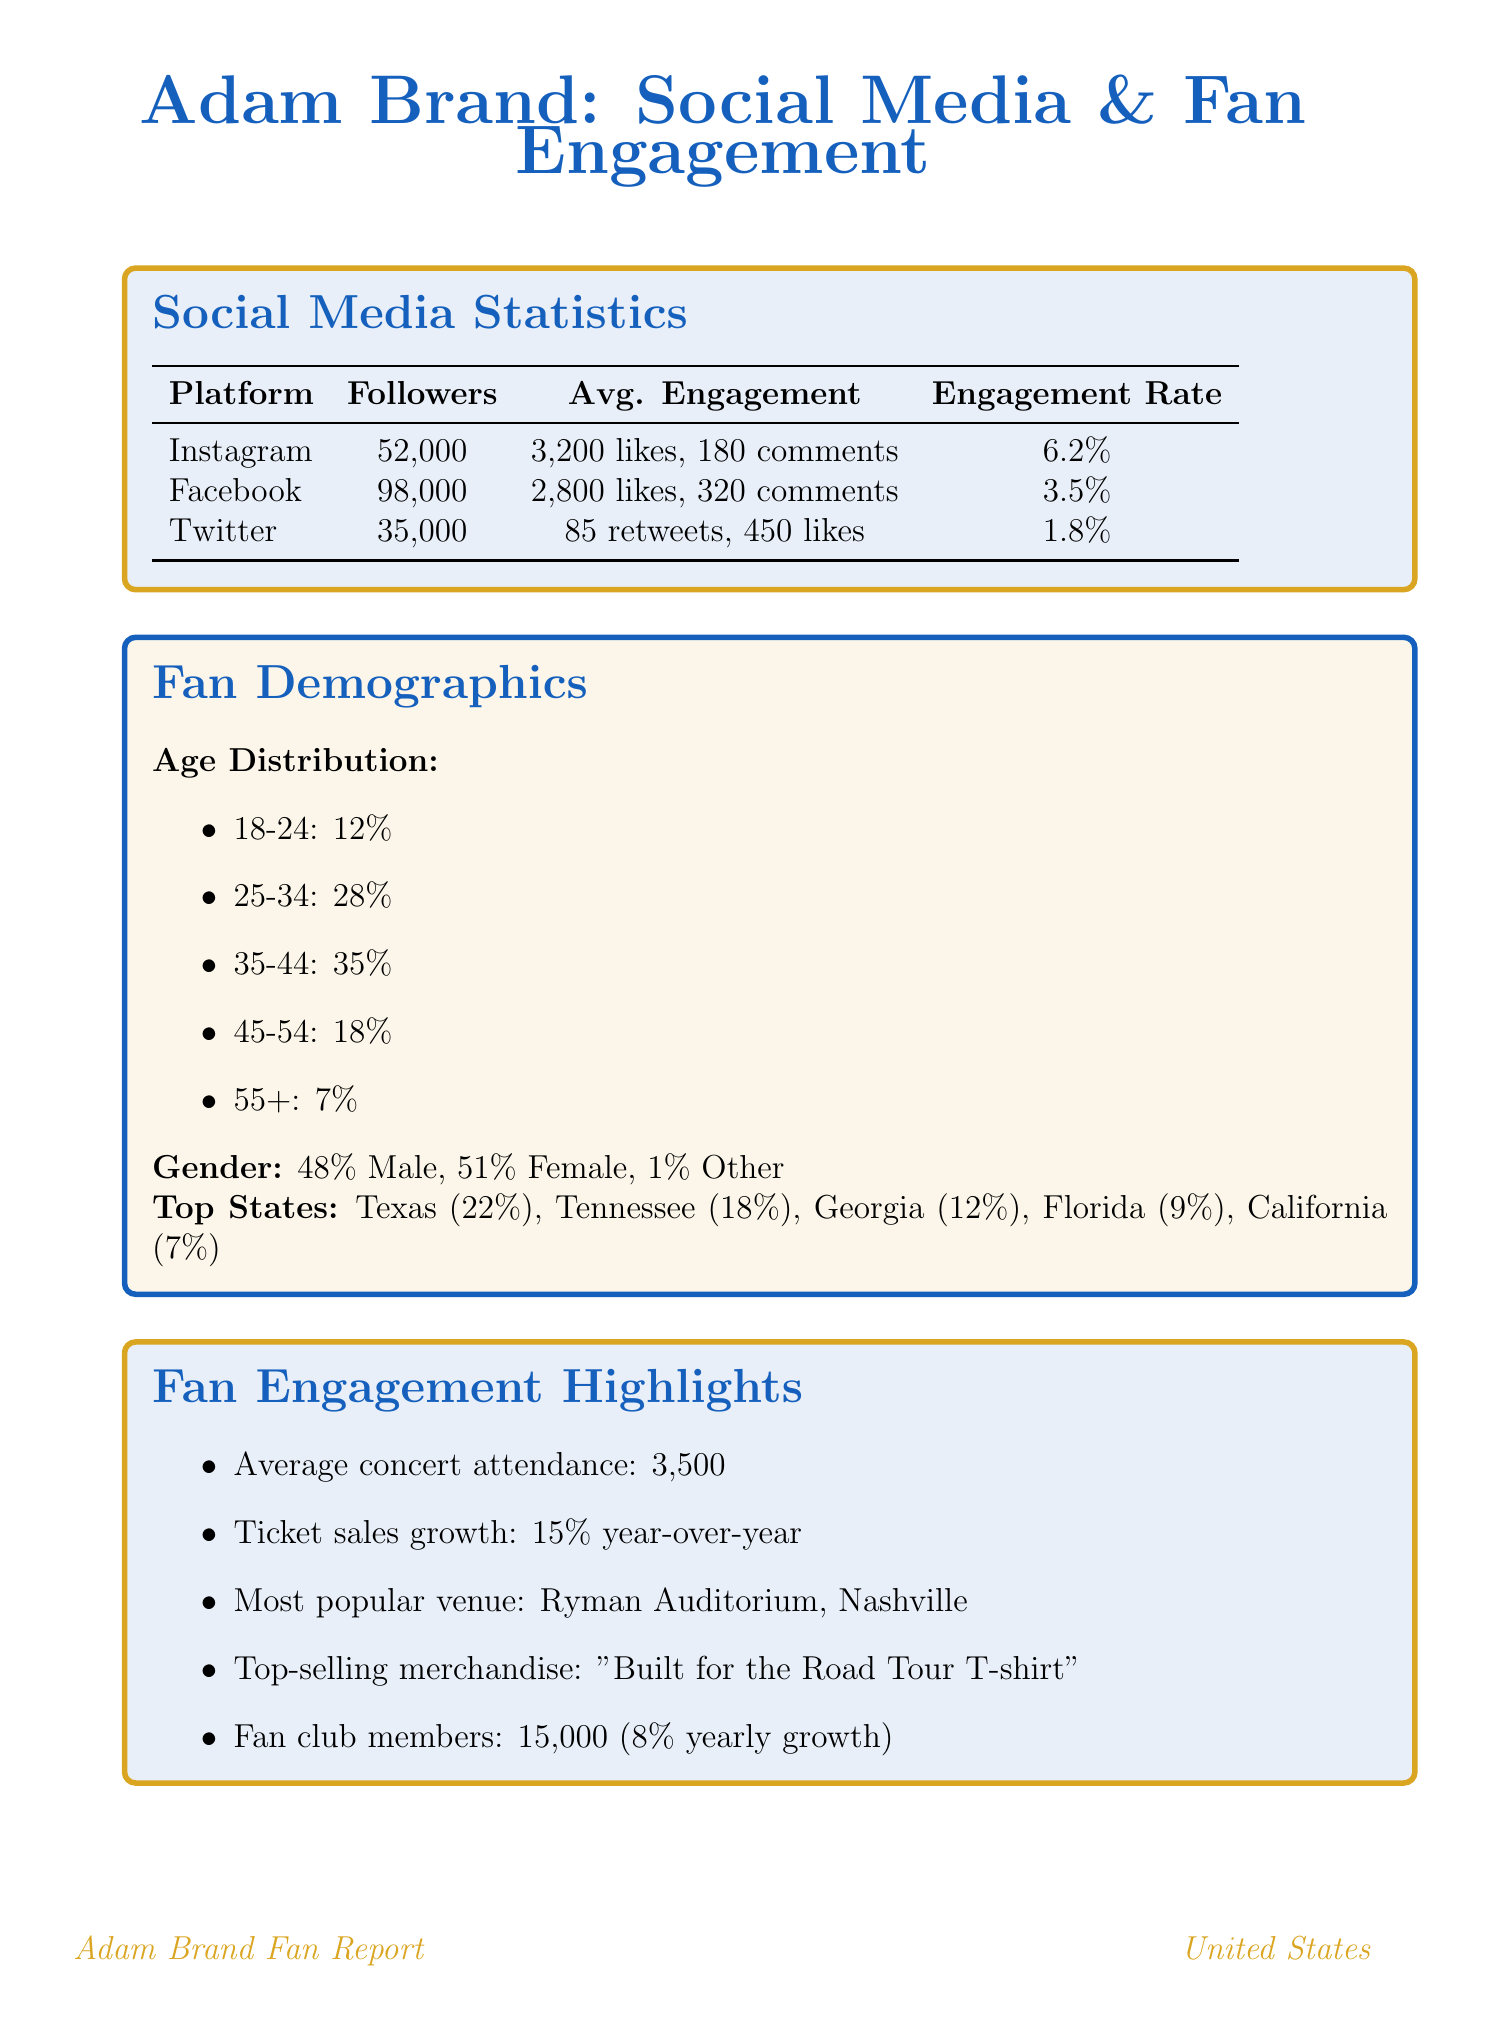What is Adam Brand's engagement rate on Instagram? The engagement rate on Instagram is a measure of interaction relative to followers, which is 6.2%.
Answer: 6.2% How many followers does Adam Brand have on Facebook? The number of followers on Facebook, as stated in the document, is 98,000.
Answer: 98,000 What is the most popular merchandise item sold? The document lists the "Built for the Road Tour T-shirt" as the top-selling item in merchandise.
Answer: Built for the Road Tour T-shirt What percentage of Adam Brand's fans are aged 35-44? The document specifies that 35% of fans fall within the age group of 35-44.
Answer: 35% Which state has the highest percentage of Adam Brand’s fans? The document indicates that Texas has the highest percentage of fans at 22%.
Answer: Texas What is the average concert attendance for Adam Brand? The average attendance for concerts shows a figure of 3,500 fans.
Answer: 3,500 How many top-streamed songs does Adam Brand have on Spotify? The average streams per song are documented as 150,000, indicating a high engagement, but no specific number of top-streamed songs is mentioned.
Answer: 150,000 What is the yearly growth rate of the fan club? The document mentions that the yearly growth rate of the fan club is 8%.
Answer: 8% In which notable venue does Adam Brand perform most frequently? The document identifies the Ryman Auditorium in Nashville as the most popular venue for performances.
Answer: Ryman Auditorium, Nashville 